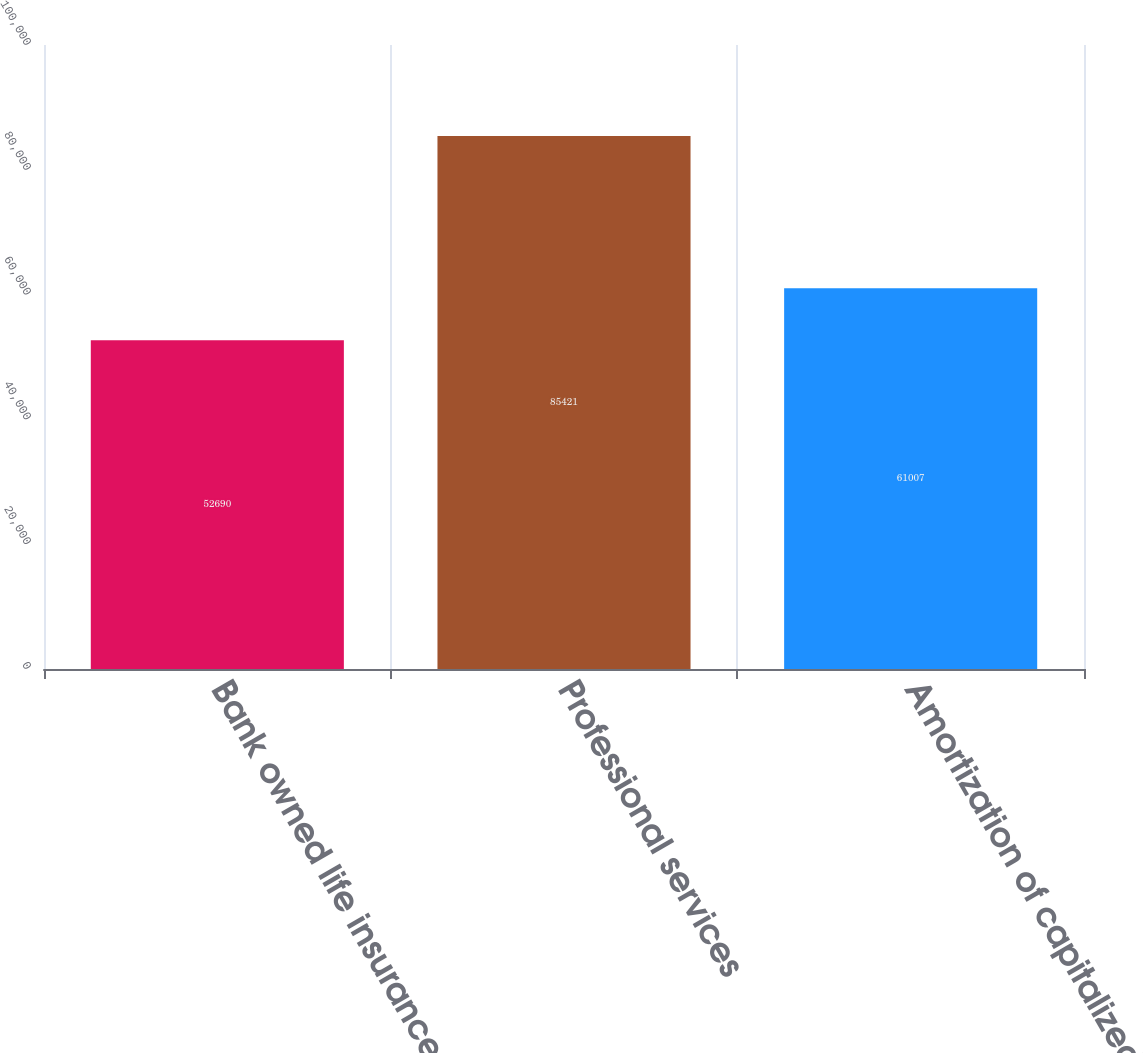Convert chart to OTSL. <chart><loc_0><loc_0><loc_500><loc_500><bar_chart><fcel>Bank owned life insurance<fcel>Professional services<fcel>Amortization of capitalized<nl><fcel>52690<fcel>85421<fcel>61007<nl></chart> 